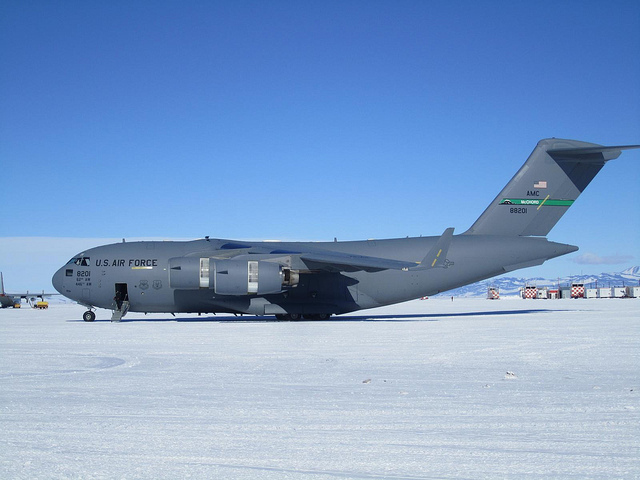Read all the text in this image. U 5 AIR FORCE 88201 AMC 